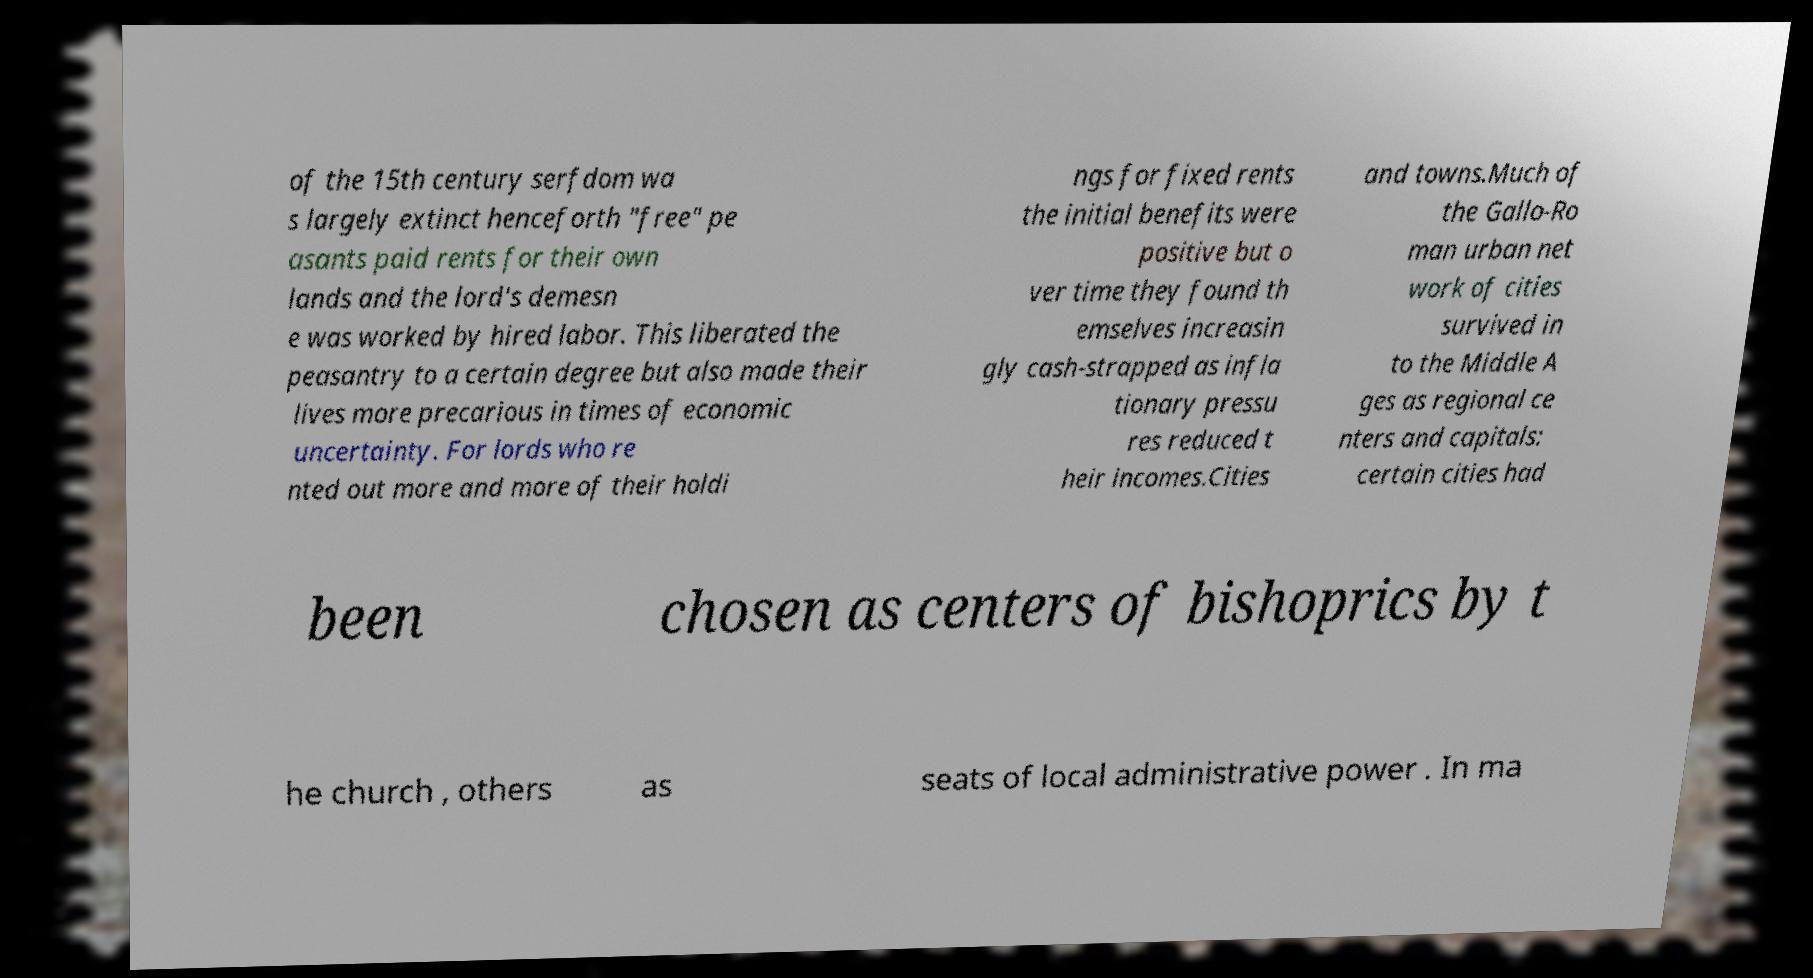Can you read and provide the text displayed in the image?This photo seems to have some interesting text. Can you extract and type it out for me? of the 15th century serfdom wa s largely extinct henceforth "free" pe asants paid rents for their own lands and the lord's demesn e was worked by hired labor. This liberated the peasantry to a certain degree but also made their lives more precarious in times of economic uncertainty. For lords who re nted out more and more of their holdi ngs for fixed rents the initial benefits were positive but o ver time they found th emselves increasin gly cash-strapped as infla tionary pressu res reduced t heir incomes.Cities and towns.Much of the Gallo-Ro man urban net work of cities survived in to the Middle A ges as regional ce nters and capitals: certain cities had been chosen as centers of bishoprics by t he church , others as seats of local administrative power . In ma 